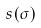Convert formula to latex. <formula><loc_0><loc_0><loc_500><loc_500>s ( \sigma )</formula> 